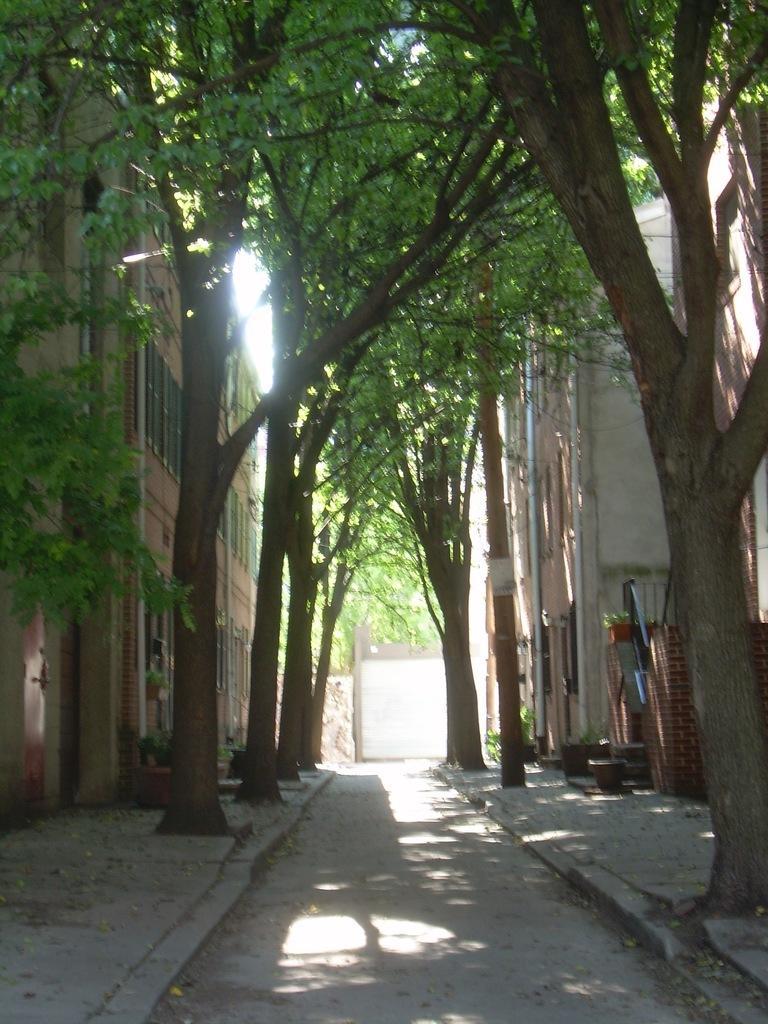Please provide a concise description of this image. At the bottom of this image there is a road. On both sides of the road there are many trees and buildings. On the right and left side of the image I can see the footpath. 